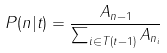<formula> <loc_0><loc_0><loc_500><loc_500>P ( n | t ) = \frac { A _ { n - 1 } } { \sum _ { i \in T ( t - 1 ) } A _ { n _ { i } } }</formula> 